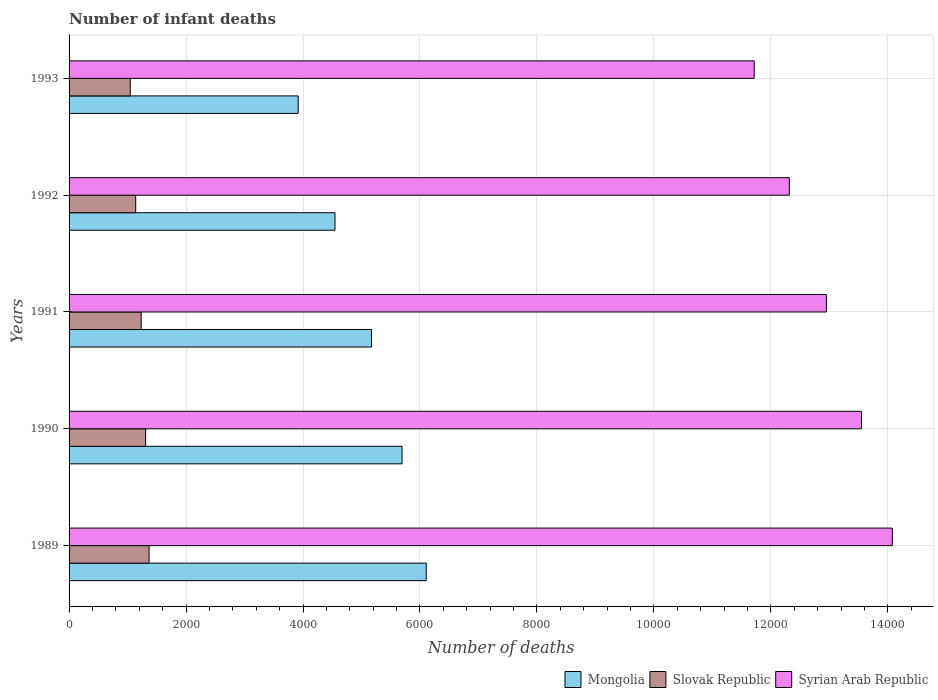How many different coloured bars are there?
Offer a very short reply. 3. How many groups of bars are there?
Your response must be concise. 5. How many bars are there on the 3rd tick from the bottom?
Your answer should be very brief. 3. What is the label of the 5th group of bars from the top?
Your answer should be very brief. 1989. What is the number of infant deaths in Syrian Arab Republic in 1993?
Offer a terse response. 1.17e+04. Across all years, what is the maximum number of infant deaths in Syrian Arab Republic?
Your answer should be compact. 1.41e+04. Across all years, what is the minimum number of infant deaths in Slovak Republic?
Your answer should be very brief. 1046. In which year was the number of infant deaths in Syrian Arab Republic minimum?
Provide a short and direct response. 1993. What is the total number of infant deaths in Mongolia in the graph?
Offer a terse response. 2.54e+04. What is the difference between the number of infant deaths in Syrian Arab Republic in 1990 and that in 1992?
Make the answer very short. 1233. What is the difference between the number of infant deaths in Mongolia in 1990 and the number of infant deaths in Slovak Republic in 1992?
Keep it short and to the point. 4554. What is the average number of infant deaths in Mongolia per year?
Provide a short and direct response. 5087. In the year 1990, what is the difference between the number of infant deaths in Mongolia and number of infant deaths in Slovak Republic?
Provide a succinct answer. 4384. What is the ratio of the number of infant deaths in Slovak Republic in 1989 to that in 1991?
Make the answer very short. 1.11. Is the number of infant deaths in Mongolia in 1989 less than that in 1990?
Your answer should be compact. No. Is the difference between the number of infant deaths in Mongolia in 1992 and 1993 greater than the difference between the number of infant deaths in Slovak Republic in 1992 and 1993?
Keep it short and to the point. Yes. What is the difference between the highest and the second highest number of infant deaths in Syrian Arab Republic?
Offer a terse response. 528. What is the difference between the highest and the lowest number of infant deaths in Slovak Republic?
Your answer should be very brief. 322. In how many years, is the number of infant deaths in Mongolia greater than the average number of infant deaths in Mongolia taken over all years?
Ensure brevity in your answer.  3. What does the 2nd bar from the top in 1991 represents?
Your answer should be compact. Slovak Republic. What does the 1st bar from the bottom in 1992 represents?
Keep it short and to the point. Mongolia. Is it the case that in every year, the sum of the number of infant deaths in Mongolia and number of infant deaths in Slovak Republic is greater than the number of infant deaths in Syrian Arab Republic?
Your answer should be very brief. No. Are all the bars in the graph horizontal?
Your response must be concise. Yes. How many years are there in the graph?
Provide a short and direct response. 5. Are the values on the major ticks of X-axis written in scientific E-notation?
Your response must be concise. No. Does the graph contain any zero values?
Give a very brief answer. No. Does the graph contain grids?
Your answer should be very brief. Yes. Where does the legend appear in the graph?
Give a very brief answer. Bottom right. How many legend labels are there?
Provide a short and direct response. 3. How are the legend labels stacked?
Keep it short and to the point. Horizontal. What is the title of the graph?
Offer a very short reply. Number of infant deaths. Does "Suriname" appear as one of the legend labels in the graph?
Provide a short and direct response. No. What is the label or title of the X-axis?
Keep it short and to the point. Number of deaths. What is the label or title of the Y-axis?
Make the answer very short. Years. What is the Number of deaths in Mongolia in 1989?
Give a very brief answer. 6107. What is the Number of deaths of Slovak Republic in 1989?
Offer a terse response. 1368. What is the Number of deaths of Syrian Arab Republic in 1989?
Provide a short and direct response. 1.41e+04. What is the Number of deaths in Mongolia in 1990?
Offer a terse response. 5693. What is the Number of deaths in Slovak Republic in 1990?
Offer a terse response. 1309. What is the Number of deaths of Syrian Arab Republic in 1990?
Give a very brief answer. 1.35e+04. What is the Number of deaths of Mongolia in 1991?
Give a very brief answer. 5171. What is the Number of deaths of Slovak Republic in 1991?
Make the answer very short. 1233. What is the Number of deaths of Syrian Arab Republic in 1991?
Offer a terse response. 1.29e+04. What is the Number of deaths in Mongolia in 1992?
Give a very brief answer. 4547. What is the Number of deaths in Slovak Republic in 1992?
Give a very brief answer. 1139. What is the Number of deaths of Syrian Arab Republic in 1992?
Your response must be concise. 1.23e+04. What is the Number of deaths of Mongolia in 1993?
Provide a succinct answer. 3917. What is the Number of deaths in Slovak Republic in 1993?
Keep it short and to the point. 1046. What is the Number of deaths in Syrian Arab Republic in 1993?
Provide a succinct answer. 1.17e+04. Across all years, what is the maximum Number of deaths in Mongolia?
Provide a short and direct response. 6107. Across all years, what is the maximum Number of deaths in Slovak Republic?
Provide a short and direct response. 1368. Across all years, what is the maximum Number of deaths of Syrian Arab Republic?
Provide a succinct answer. 1.41e+04. Across all years, what is the minimum Number of deaths in Mongolia?
Keep it short and to the point. 3917. Across all years, what is the minimum Number of deaths in Slovak Republic?
Give a very brief answer. 1046. Across all years, what is the minimum Number of deaths in Syrian Arab Republic?
Provide a succinct answer. 1.17e+04. What is the total Number of deaths in Mongolia in the graph?
Make the answer very short. 2.54e+04. What is the total Number of deaths of Slovak Republic in the graph?
Offer a terse response. 6095. What is the total Number of deaths in Syrian Arab Republic in the graph?
Offer a very short reply. 6.46e+04. What is the difference between the Number of deaths of Mongolia in 1989 and that in 1990?
Provide a succinct answer. 414. What is the difference between the Number of deaths of Slovak Republic in 1989 and that in 1990?
Offer a very short reply. 59. What is the difference between the Number of deaths in Syrian Arab Republic in 1989 and that in 1990?
Provide a short and direct response. 528. What is the difference between the Number of deaths in Mongolia in 1989 and that in 1991?
Ensure brevity in your answer.  936. What is the difference between the Number of deaths of Slovak Republic in 1989 and that in 1991?
Provide a succinct answer. 135. What is the difference between the Number of deaths of Syrian Arab Republic in 1989 and that in 1991?
Offer a terse response. 1128. What is the difference between the Number of deaths of Mongolia in 1989 and that in 1992?
Provide a short and direct response. 1560. What is the difference between the Number of deaths of Slovak Republic in 1989 and that in 1992?
Keep it short and to the point. 229. What is the difference between the Number of deaths of Syrian Arab Republic in 1989 and that in 1992?
Give a very brief answer. 1761. What is the difference between the Number of deaths of Mongolia in 1989 and that in 1993?
Your answer should be compact. 2190. What is the difference between the Number of deaths in Slovak Republic in 1989 and that in 1993?
Keep it short and to the point. 322. What is the difference between the Number of deaths of Syrian Arab Republic in 1989 and that in 1993?
Make the answer very short. 2362. What is the difference between the Number of deaths of Mongolia in 1990 and that in 1991?
Offer a very short reply. 522. What is the difference between the Number of deaths in Syrian Arab Republic in 1990 and that in 1991?
Keep it short and to the point. 600. What is the difference between the Number of deaths of Mongolia in 1990 and that in 1992?
Your response must be concise. 1146. What is the difference between the Number of deaths of Slovak Republic in 1990 and that in 1992?
Make the answer very short. 170. What is the difference between the Number of deaths in Syrian Arab Republic in 1990 and that in 1992?
Provide a short and direct response. 1233. What is the difference between the Number of deaths in Mongolia in 1990 and that in 1993?
Make the answer very short. 1776. What is the difference between the Number of deaths in Slovak Republic in 1990 and that in 1993?
Make the answer very short. 263. What is the difference between the Number of deaths in Syrian Arab Republic in 1990 and that in 1993?
Provide a succinct answer. 1834. What is the difference between the Number of deaths of Mongolia in 1991 and that in 1992?
Your answer should be very brief. 624. What is the difference between the Number of deaths in Slovak Republic in 1991 and that in 1992?
Make the answer very short. 94. What is the difference between the Number of deaths of Syrian Arab Republic in 1991 and that in 1992?
Provide a short and direct response. 633. What is the difference between the Number of deaths in Mongolia in 1991 and that in 1993?
Your response must be concise. 1254. What is the difference between the Number of deaths of Slovak Republic in 1991 and that in 1993?
Offer a very short reply. 187. What is the difference between the Number of deaths of Syrian Arab Republic in 1991 and that in 1993?
Give a very brief answer. 1234. What is the difference between the Number of deaths of Mongolia in 1992 and that in 1993?
Your response must be concise. 630. What is the difference between the Number of deaths of Slovak Republic in 1992 and that in 1993?
Make the answer very short. 93. What is the difference between the Number of deaths in Syrian Arab Republic in 1992 and that in 1993?
Your answer should be very brief. 601. What is the difference between the Number of deaths of Mongolia in 1989 and the Number of deaths of Slovak Republic in 1990?
Offer a very short reply. 4798. What is the difference between the Number of deaths of Mongolia in 1989 and the Number of deaths of Syrian Arab Republic in 1990?
Give a very brief answer. -7441. What is the difference between the Number of deaths in Slovak Republic in 1989 and the Number of deaths in Syrian Arab Republic in 1990?
Offer a terse response. -1.22e+04. What is the difference between the Number of deaths in Mongolia in 1989 and the Number of deaths in Slovak Republic in 1991?
Provide a short and direct response. 4874. What is the difference between the Number of deaths of Mongolia in 1989 and the Number of deaths of Syrian Arab Republic in 1991?
Keep it short and to the point. -6841. What is the difference between the Number of deaths of Slovak Republic in 1989 and the Number of deaths of Syrian Arab Republic in 1991?
Make the answer very short. -1.16e+04. What is the difference between the Number of deaths of Mongolia in 1989 and the Number of deaths of Slovak Republic in 1992?
Your answer should be compact. 4968. What is the difference between the Number of deaths of Mongolia in 1989 and the Number of deaths of Syrian Arab Republic in 1992?
Your answer should be compact. -6208. What is the difference between the Number of deaths in Slovak Republic in 1989 and the Number of deaths in Syrian Arab Republic in 1992?
Ensure brevity in your answer.  -1.09e+04. What is the difference between the Number of deaths in Mongolia in 1989 and the Number of deaths in Slovak Republic in 1993?
Provide a succinct answer. 5061. What is the difference between the Number of deaths of Mongolia in 1989 and the Number of deaths of Syrian Arab Republic in 1993?
Your answer should be compact. -5607. What is the difference between the Number of deaths of Slovak Republic in 1989 and the Number of deaths of Syrian Arab Republic in 1993?
Your answer should be very brief. -1.03e+04. What is the difference between the Number of deaths of Mongolia in 1990 and the Number of deaths of Slovak Republic in 1991?
Your response must be concise. 4460. What is the difference between the Number of deaths of Mongolia in 1990 and the Number of deaths of Syrian Arab Republic in 1991?
Give a very brief answer. -7255. What is the difference between the Number of deaths of Slovak Republic in 1990 and the Number of deaths of Syrian Arab Republic in 1991?
Offer a very short reply. -1.16e+04. What is the difference between the Number of deaths of Mongolia in 1990 and the Number of deaths of Slovak Republic in 1992?
Your answer should be compact. 4554. What is the difference between the Number of deaths in Mongolia in 1990 and the Number of deaths in Syrian Arab Republic in 1992?
Make the answer very short. -6622. What is the difference between the Number of deaths of Slovak Republic in 1990 and the Number of deaths of Syrian Arab Republic in 1992?
Keep it short and to the point. -1.10e+04. What is the difference between the Number of deaths of Mongolia in 1990 and the Number of deaths of Slovak Republic in 1993?
Make the answer very short. 4647. What is the difference between the Number of deaths of Mongolia in 1990 and the Number of deaths of Syrian Arab Republic in 1993?
Provide a succinct answer. -6021. What is the difference between the Number of deaths of Slovak Republic in 1990 and the Number of deaths of Syrian Arab Republic in 1993?
Your response must be concise. -1.04e+04. What is the difference between the Number of deaths in Mongolia in 1991 and the Number of deaths in Slovak Republic in 1992?
Ensure brevity in your answer.  4032. What is the difference between the Number of deaths of Mongolia in 1991 and the Number of deaths of Syrian Arab Republic in 1992?
Give a very brief answer. -7144. What is the difference between the Number of deaths of Slovak Republic in 1991 and the Number of deaths of Syrian Arab Republic in 1992?
Keep it short and to the point. -1.11e+04. What is the difference between the Number of deaths in Mongolia in 1991 and the Number of deaths in Slovak Republic in 1993?
Provide a succinct answer. 4125. What is the difference between the Number of deaths in Mongolia in 1991 and the Number of deaths in Syrian Arab Republic in 1993?
Your response must be concise. -6543. What is the difference between the Number of deaths of Slovak Republic in 1991 and the Number of deaths of Syrian Arab Republic in 1993?
Keep it short and to the point. -1.05e+04. What is the difference between the Number of deaths of Mongolia in 1992 and the Number of deaths of Slovak Republic in 1993?
Offer a very short reply. 3501. What is the difference between the Number of deaths of Mongolia in 1992 and the Number of deaths of Syrian Arab Republic in 1993?
Offer a very short reply. -7167. What is the difference between the Number of deaths in Slovak Republic in 1992 and the Number of deaths in Syrian Arab Republic in 1993?
Offer a terse response. -1.06e+04. What is the average Number of deaths of Mongolia per year?
Your answer should be compact. 5087. What is the average Number of deaths in Slovak Republic per year?
Ensure brevity in your answer.  1219. What is the average Number of deaths in Syrian Arab Republic per year?
Provide a short and direct response. 1.29e+04. In the year 1989, what is the difference between the Number of deaths of Mongolia and Number of deaths of Slovak Republic?
Offer a very short reply. 4739. In the year 1989, what is the difference between the Number of deaths of Mongolia and Number of deaths of Syrian Arab Republic?
Keep it short and to the point. -7969. In the year 1989, what is the difference between the Number of deaths in Slovak Republic and Number of deaths in Syrian Arab Republic?
Provide a short and direct response. -1.27e+04. In the year 1990, what is the difference between the Number of deaths of Mongolia and Number of deaths of Slovak Republic?
Provide a succinct answer. 4384. In the year 1990, what is the difference between the Number of deaths in Mongolia and Number of deaths in Syrian Arab Republic?
Offer a very short reply. -7855. In the year 1990, what is the difference between the Number of deaths in Slovak Republic and Number of deaths in Syrian Arab Republic?
Keep it short and to the point. -1.22e+04. In the year 1991, what is the difference between the Number of deaths in Mongolia and Number of deaths in Slovak Republic?
Offer a terse response. 3938. In the year 1991, what is the difference between the Number of deaths of Mongolia and Number of deaths of Syrian Arab Republic?
Provide a succinct answer. -7777. In the year 1991, what is the difference between the Number of deaths in Slovak Republic and Number of deaths in Syrian Arab Republic?
Ensure brevity in your answer.  -1.17e+04. In the year 1992, what is the difference between the Number of deaths in Mongolia and Number of deaths in Slovak Republic?
Your response must be concise. 3408. In the year 1992, what is the difference between the Number of deaths in Mongolia and Number of deaths in Syrian Arab Republic?
Offer a terse response. -7768. In the year 1992, what is the difference between the Number of deaths in Slovak Republic and Number of deaths in Syrian Arab Republic?
Ensure brevity in your answer.  -1.12e+04. In the year 1993, what is the difference between the Number of deaths of Mongolia and Number of deaths of Slovak Republic?
Your answer should be very brief. 2871. In the year 1993, what is the difference between the Number of deaths in Mongolia and Number of deaths in Syrian Arab Republic?
Offer a terse response. -7797. In the year 1993, what is the difference between the Number of deaths in Slovak Republic and Number of deaths in Syrian Arab Republic?
Your answer should be very brief. -1.07e+04. What is the ratio of the Number of deaths in Mongolia in 1989 to that in 1990?
Provide a succinct answer. 1.07. What is the ratio of the Number of deaths in Slovak Republic in 1989 to that in 1990?
Your response must be concise. 1.05. What is the ratio of the Number of deaths of Syrian Arab Republic in 1989 to that in 1990?
Keep it short and to the point. 1.04. What is the ratio of the Number of deaths of Mongolia in 1989 to that in 1991?
Your response must be concise. 1.18. What is the ratio of the Number of deaths in Slovak Republic in 1989 to that in 1991?
Your response must be concise. 1.11. What is the ratio of the Number of deaths of Syrian Arab Republic in 1989 to that in 1991?
Keep it short and to the point. 1.09. What is the ratio of the Number of deaths of Mongolia in 1989 to that in 1992?
Make the answer very short. 1.34. What is the ratio of the Number of deaths of Slovak Republic in 1989 to that in 1992?
Keep it short and to the point. 1.2. What is the ratio of the Number of deaths in Syrian Arab Republic in 1989 to that in 1992?
Offer a terse response. 1.14. What is the ratio of the Number of deaths of Mongolia in 1989 to that in 1993?
Make the answer very short. 1.56. What is the ratio of the Number of deaths in Slovak Republic in 1989 to that in 1993?
Make the answer very short. 1.31. What is the ratio of the Number of deaths in Syrian Arab Republic in 1989 to that in 1993?
Provide a short and direct response. 1.2. What is the ratio of the Number of deaths of Mongolia in 1990 to that in 1991?
Your response must be concise. 1.1. What is the ratio of the Number of deaths of Slovak Republic in 1990 to that in 1991?
Your response must be concise. 1.06. What is the ratio of the Number of deaths in Syrian Arab Republic in 1990 to that in 1991?
Your answer should be very brief. 1.05. What is the ratio of the Number of deaths in Mongolia in 1990 to that in 1992?
Give a very brief answer. 1.25. What is the ratio of the Number of deaths in Slovak Republic in 1990 to that in 1992?
Offer a very short reply. 1.15. What is the ratio of the Number of deaths of Syrian Arab Republic in 1990 to that in 1992?
Your answer should be very brief. 1.1. What is the ratio of the Number of deaths of Mongolia in 1990 to that in 1993?
Provide a succinct answer. 1.45. What is the ratio of the Number of deaths in Slovak Republic in 1990 to that in 1993?
Your answer should be very brief. 1.25. What is the ratio of the Number of deaths of Syrian Arab Republic in 1990 to that in 1993?
Your answer should be compact. 1.16. What is the ratio of the Number of deaths of Mongolia in 1991 to that in 1992?
Your answer should be very brief. 1.14. What is the ratio of the Number of deaths in Slovak Republic in 1991 to that in 1992?
Ensure brevity in your answer.  1.08. What is the ratio of the Number of deaths in Syrian Arab Republic in 1991 to that in 1992?
Your answer should be compact. 1.05. What is the ratio of the Number of deaths of Mongolia in 1991 to that in 1993?
Offer a very short reply. 1.32. What is the ratio of the Number of deaths in Slovak Republic in 1991 to that in 1993?
Provide a short and direct response. 1.18. What is the ratio of the Number of deaths of Syrian Arab Republic in 1991 to that in 1993?
Make the answer very short. 1.11. What is the ratio of the Number of deaths of Mongolia in 1992 to that in 1993?
Your response must be concise. 1.16. What is the ratio of the Number of deaths of Slovak Republic in 1992 to that in 1993?
Offer a very short reply. 1.09. What is the ratio of the Number of deaths of Syrian Arab Republic in 1992 to that in 1993?
Your response must be concise. 1.05. What is the difference between the highest and the second highest Number of deaths of Mongolia?
Give a very brief answer. 414. What is the difference between the highest and the second highest Number of deaths in Slovak Republic?
Your response must be concise. 59. What is the difference between the highest and the second highest Number of deaths of Syrian Arab Republic?
Your answer should be compact. 528. What is the difference between the highest and the lowest Number of deaths of Mongolia?
Your answer should be very brief. 2190. What is the difference between the highest and the lowest Number of deaths in Slovak Republic?
Provide a succinct answer. 322. What is the difference between the highest and the lowest Number of deaths of Syrian Arab Republic?
Keep it short and to the point. 2362. 